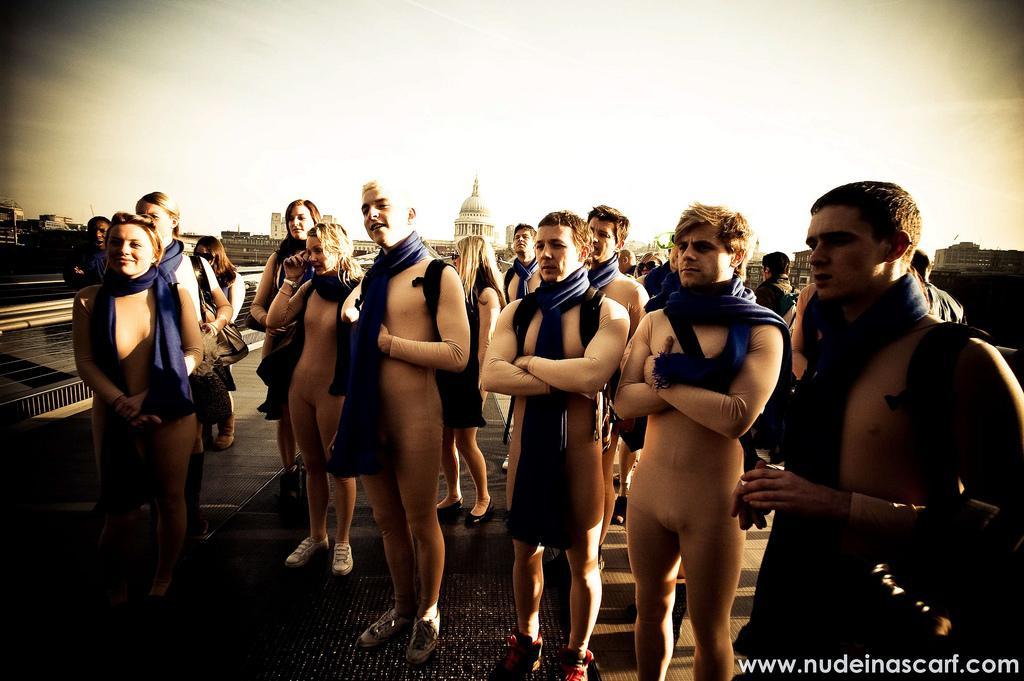How would you summarize this image in a sentence or two? In the image in the center, we can see a few people are standing. And few people are smiling, which we can see on their faces. And we can see few people are wearing backpacks. In the bottom right of the image, we can see something written. In the background, we can see the sky, buildings and a fence. 